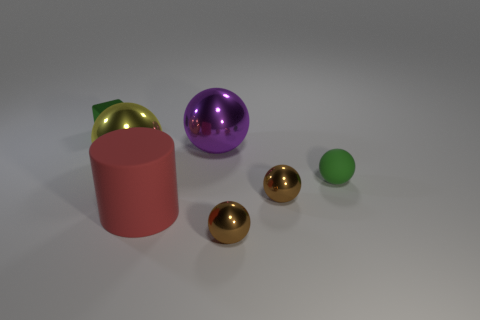What is the size of the green thing that is to the left of the green object that is to the right of the tiny green shiny thing?
Give a very brief answer. Small. Is there any other thing that is the same shape as the purple shiny object?
Offer a terse response. Yes. Are there fewer yellow rubber blocks than metal cubes?
Provide a succinct answer. Yes. There is a object that is in front of the cube and on the left side of the big matte thing; what material is it?
Ensure brevity in your answer.  Metal. Is there a big yellow metallic thing that is on the left side of the yellow sphere to the left of the rubber ball?
Your response must be concise. No. How many objects are either large yellow metallic balls or big rubber things?
Your answer should be very brief. 2. The shiny thing that is both right of the red thing and behind the small green matte object has what shape?
Your answer should be very brief. Sphere. Do the small green thing that is in front of the green metal cube and the big red cylinder have the same material?
Keep it short and to the point. Yes. How many objects are either big yellow spheres or brown metallic objects that are in front of the cylinder?
Your answer should be compact. 2. There is a large cylinder that is the same material as the green ball; what is its color?
Your answer should be compact. Red. 